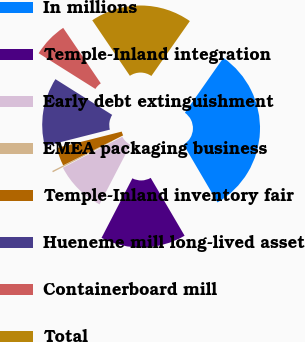Convert chart. <chart><loc_0><loc_0><loc_500><loc_500><pie_chart><fcel>In millions<fcel>Temple-Inland integration<fcel>Early debt extinguishment<fcel>EMEA packaging business<fcel>Temple-Inland inventory fair<fcel>Hueneme mill long-lived asset<fcel>Containerboard mill<fcel>Total<nl><fcel>31.83%<fcel>16.05%<fcel>9.74%<fcel>0.27%<fcel>3.43%<fcel>12.89%<fcel>6.58%<fcel>19.21%<nl></chart> 